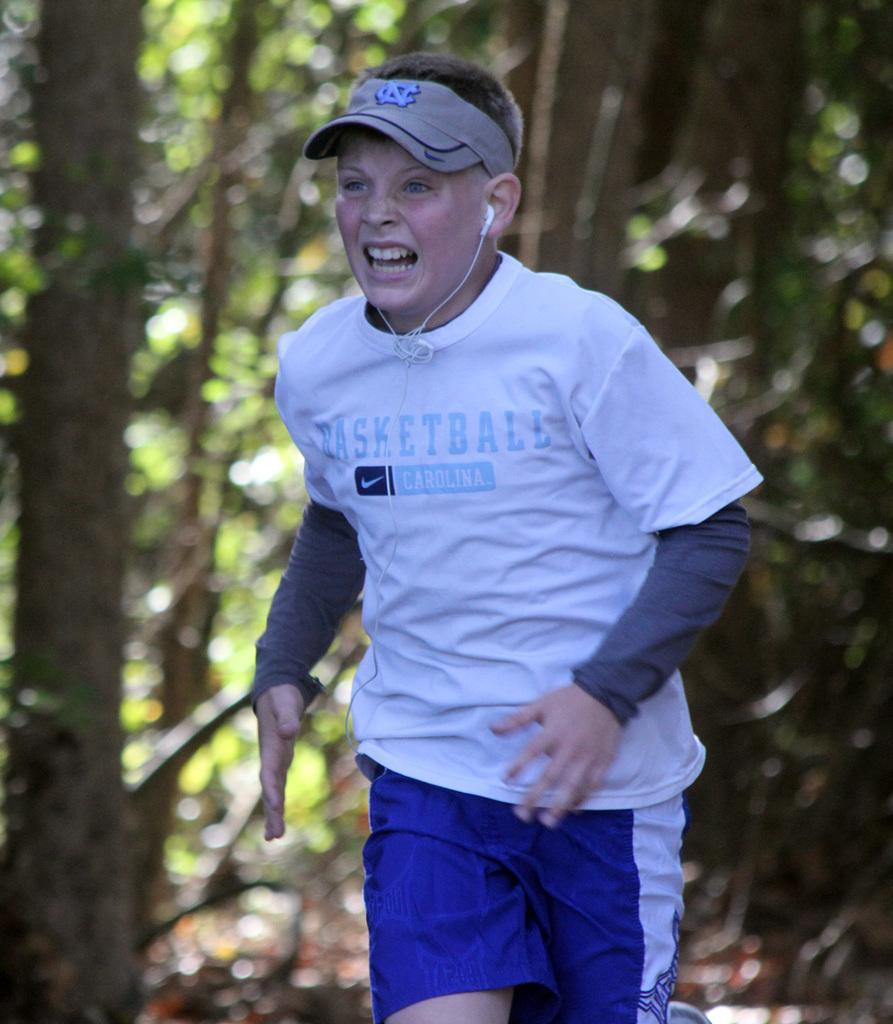Who or what is the main subject in the image? There is a person in the image. What can be seen in the background of the image? There are many trees in the image. What is the person wearing on their head? The person is wearing a cap. What is written on the person's T-shirt? There is some text on the person's T-shirt. How would you describe the overall focus of the image? The background of the image is blurred. Where is the drain located in the image? There is no drain present in the image. What type of advertisement can be seen on the trees in the image? There are no advertisements on the trees in the image; it primarily features trees and a person. 